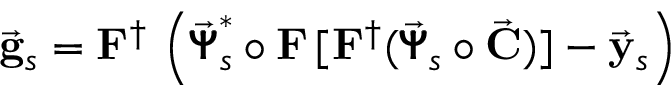<formula> <loc_0><loc_0><loc_500><loc_500>\vec { g } _ { s } = { F } ^ { \dagger } \, \left ( \vec { \pm b { \Psi } } _ { s } ^ { * } \circ { F } \, [ { F } ^ { \dagger } ( \vec { \pm b { \Psi } } _ { s } \circ \vec { C } ) ] - \vec { y } _ { s } \right )</formula> 